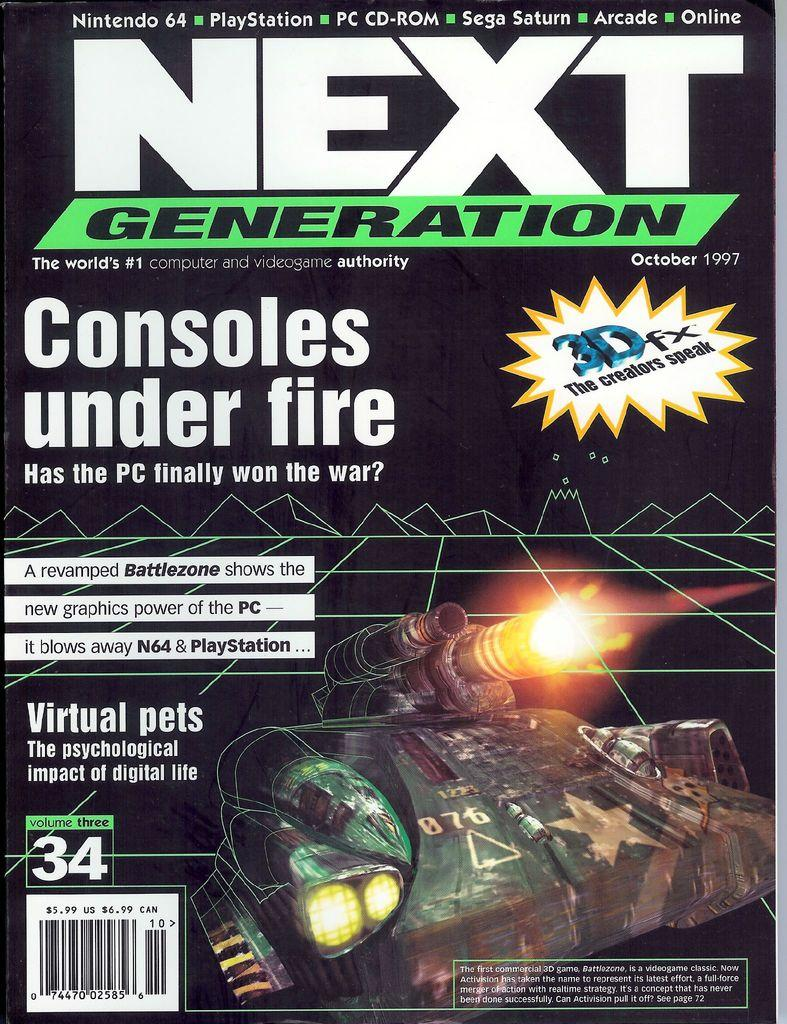What is present on the poster in the image? The poster contains text and a picture. Can you describe the content of the poster? The poster contains text and a picture, but the specific content cannot be determined from the provided facts. What type of twig is being used to perform an action in the image? There is no twig or action present in the image; it only contains a poster with text and a picture. 